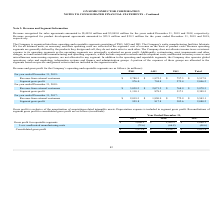From On Semiconductor's financial document, How much Revenue was recognized for sales agreements for the years ended December 31, 2019 and 2018 respectively? The document shows two values: $5,492.0 million and $5,849.0 million. From the document: "sales agreements amounted to $5,492.0 million and $5,849.0 million for the years ended December 31, 2019 and 2018, respectively. Revenue recognized fo..." Also, How much Revenue was recognized for product development agreements for the years ended December 31, 2019 and 2018 respectively? The document shows two values: $25.9 million and $29.3 million. From the document: "velopment agreements amounted to $25.9 million and $29.3 million for the years ended December 31, 2019 and 2018, respectively. zed for product develop..." Also, What are the three operating and reportable segments? The document contains multiple relevant values: PSG, ASG, ISG.. From the document: "rating and reportable segments consisting of PSG, ASG and ISG. The Company's wafer manufacturing facilities fabricate ICs for all business units, as n..." Also, can you calculate: What is the change in PSG Revenue from external customers from year ended December 31, 2018 to 2019? Based on the calculation: 2,788.3-3,038.2, the result is -249.9 (in millions). This is based on the information: "Revenue from external customers $ 2,788.3 $ 1,972.3 $ 757.3 $ 5,517.9 Revenue from external customers $ 3,038.2 $ 2,071.2 $ 768.9 $ 5,878.3..." The key data points involved are: 2,788.3, 3,038.2. Also, can you calculate: What is the change in ASG Revenue from external customers from year ended December 31, 2018 to 2019? Based on the calculation: 1,972.3-2,071.2, the result is -98.9 (in millions). This is based on the information: "Revenue from external customers $ 3,038.2 $ 2,071.2 $ 768.9 $ 5,878.3 Revenue from external customers $ 2,788.3 $ 1,972.3 $ 757.3 $ 5,517.9..." The key data points involved are: 1,972.3, 2,071.2. Also, can you calculate: What is the average PSG Revenue from external customers for year ended December 31, 2018 to 2019? To answer this question, I need to perform calculations using the financial data. The calculation is: (2,788.3+3,038.2) / 2, which equals 2913.25 (in millions). This is based on the information: "Revenue from external customers $ 2,788.3 $ 1,972.3 $ 757.3 $ 5,517.9 Revenue from external customers $ 3,038.2 $ 2,071.2 $ 768.9 $ 5,878.3..." The key data points involved are: 2,788.3, 3,038.2. 